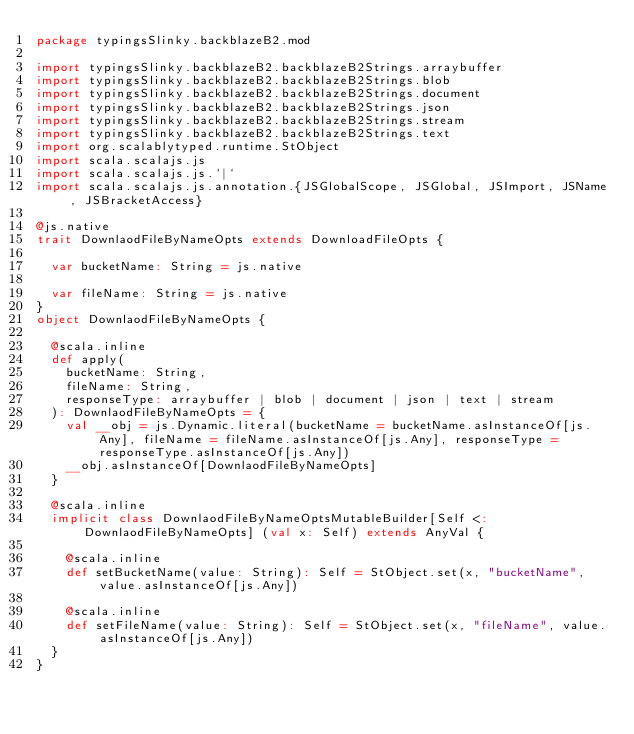<code> <loc_0><loc_0><loc_500><loc_500><_Scala_>package typingsSlinky.backblazeB2.mod

import typingsSlinky.backblazeB2.backblazeB2Strings.arraybuffer
import typingsSlinky.backblazeB2.backblazeB2Strings.blob
import typingsSlinky.backblazeB2.backblazeB2Strings.document
import typingsSlinky.backblazeB2.backblazeB2Strings.json
import typingsSlinky.backblazeB2.backblazeB2Strings.stream
import typingsSlinky.backblazeB2.backblazeB2Strings.text
import org.scalablytyped.runtime.StObject
import scala.scalajs.js
import scala.scalajs.js.`|`
import scala.scalajs.js.annotation.{JSGlobalScope, JSGlobal, JSImport, JSName, JSBracketAccess}

@js.native
trait DownlaodFileByNameOpts extends DownloadFileOpts {
  
  var bucketName: String = js.native
  
  var fileName: String = js.native
}
object DownlaodFileByNameOpts {
  
  @scala.inline
  def apply(
    bucketName: String,
    fileName: String,
    responseType: arraybuffer | blob | document | json | text | stream
  ): DownlaodFileByNameOpts = {
    val __obj = js.Dynamic.literal(bucketName = bucketName.asInstanceOf[js.Any], fileName = fileName.asInstanceOf[js.Any], responseType = responseType.asInstanceOf[js.Any])
    __obj.asInstanceOf[DownlaodFileByNameOpts]
  }
  
  @scala.inline
  implicit class DownlaodFileByNameOptsMutableBuilder[Self <: DownlaodFileByNameOpts] (val x: Self) extends AnyVal {
    
    @scala.inline
    def setBucketName(value: String): Self = StObject.set(x, "bucketName", value.asInstanceOf[js.Any])
    
    @scala.inline
    def setFileName(value: String): Self = StObject.set(x, "fileName", value.asInstanceOf[js.Any])
  }
}
</code> 